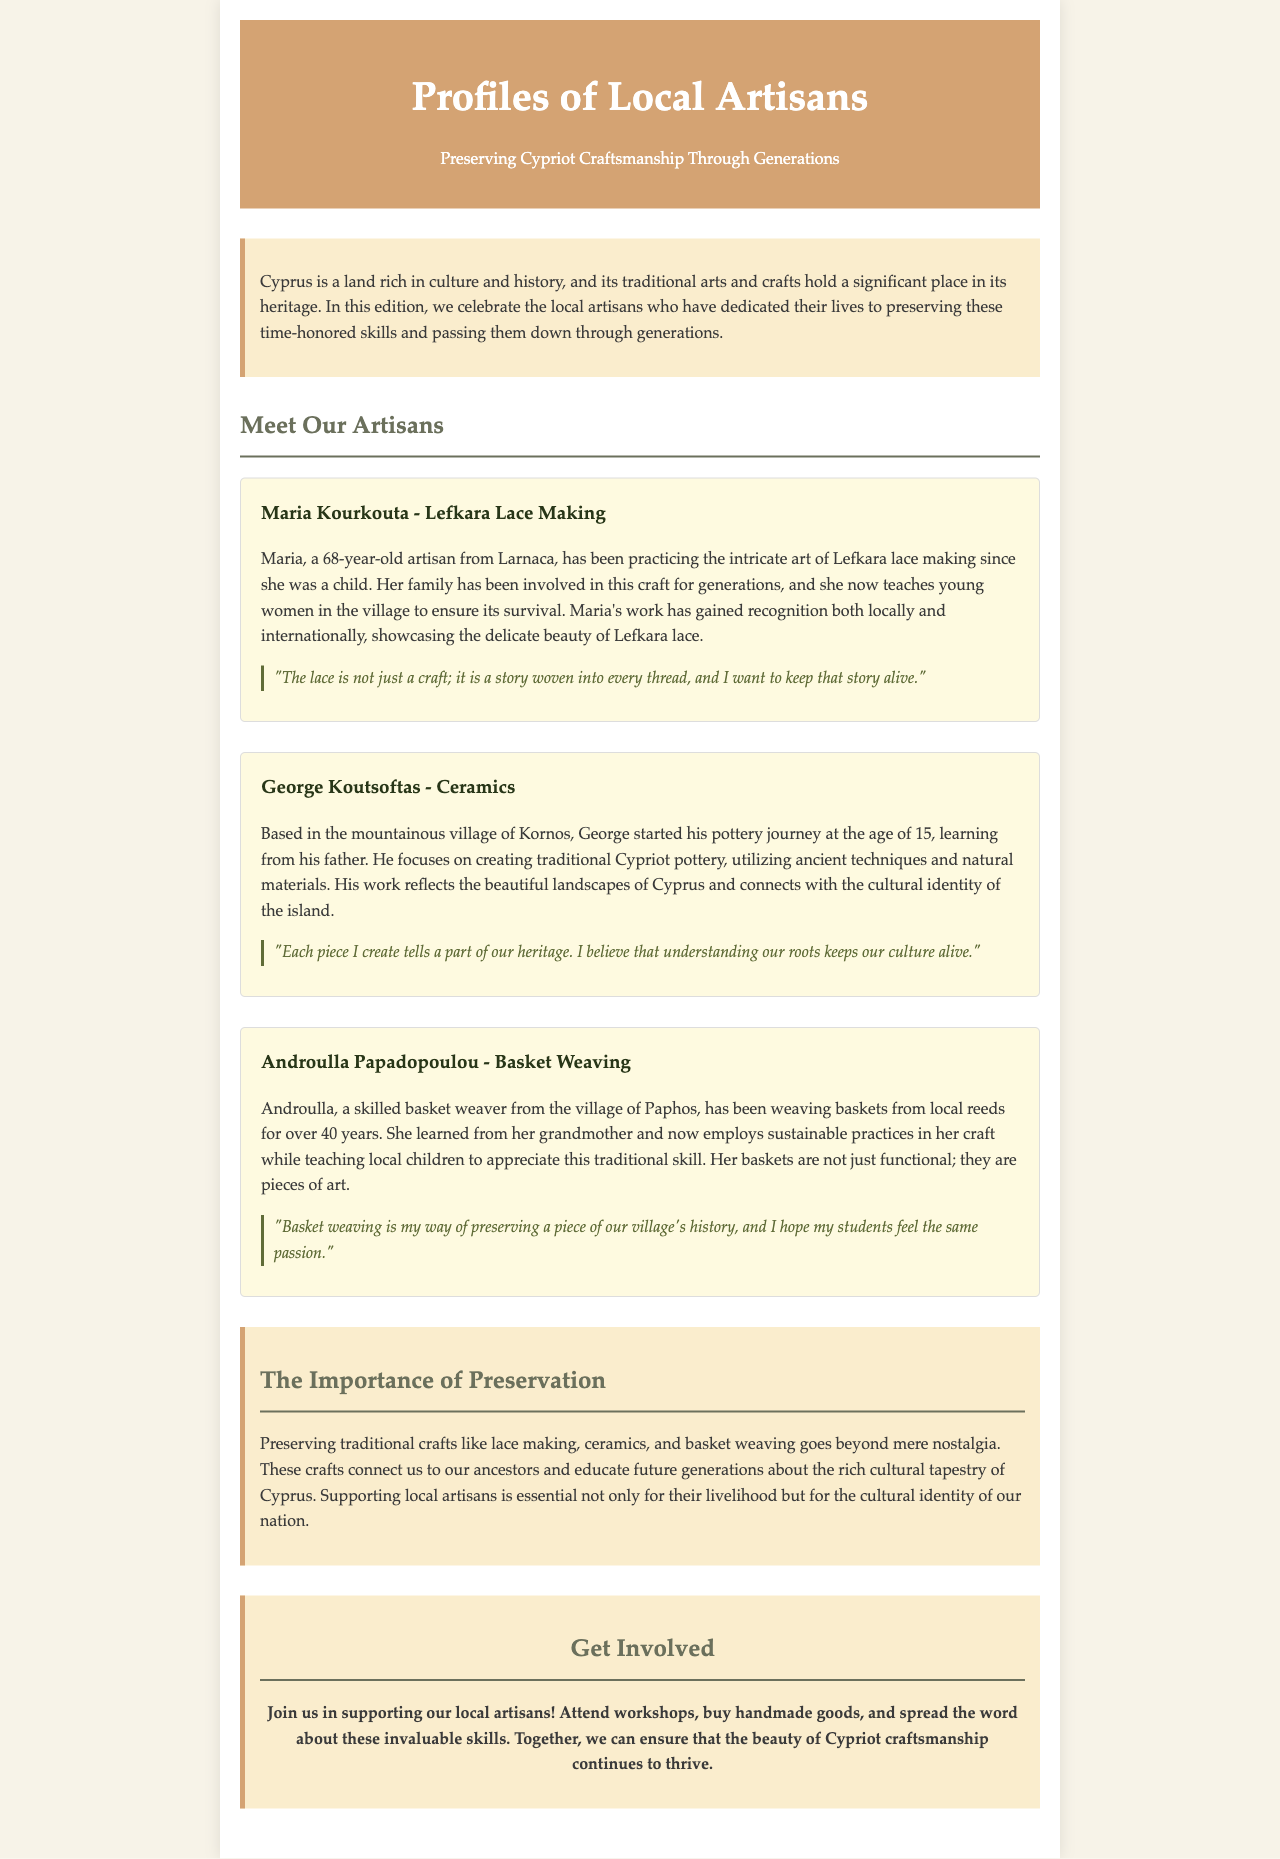What is the main theme of the newsletter? The theme revolves around celebrating local artisans who preserve traditional Cypriot crafts.
Answer: Preserving Cypriot Craftsmanship Through Generations Who is the artisan associated with Lefkara lace making? The artisan known for Lefkara lace making mentioned in the document is Maria Kourkouta.
Answer: Maria Kourkouta What age did George Koutsoftas start his pottery journey? The document states that George started his pottery journey at the age of 15.
Answer: 15 What material does Androulla Papadopoulou use for basket weaving? Androulla weaves baskets from local reeds as explained in her profile.
Answer: Local reeds How many years has Androulla been weaving baskets? It is indicated that Androulla has been weaving baskets for over 40 years.
Answer: Over 40 years What is the quote associated with George Koutsoftas about his creations? The quote emphasizes that each piece he creates tells a part of their heritage.
Answer: "Each piece I create tells a part of our heritage." What is one suggested way to support local artisans? The document encourages attending workshops as one way to support local artisans.
Answer: Attend workshops Why is preserving traditional crafts important according to the document? The importance lies in connecting us to our ancestors and educating future generations.
Answer: It connects us to our ancestors 